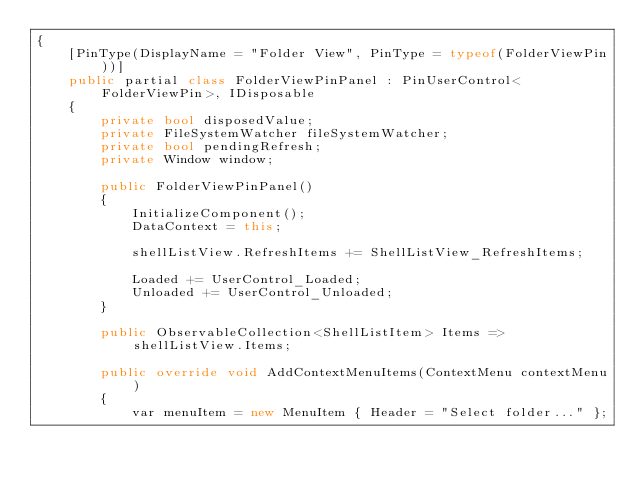<code> <loc_0><loc_0><loc_500><loc_500><_C#_>{
    [PinType(DisplayName = "Folder View", PinType = typeof(FolderViewPin))]
    public partial class FolderViewPinPanel : PinUserControl<FolderViewPin>, IDisposable
    {
        private bool disposedValue;
        private FileSystemWatcher fileSystemWatcher;
        private bool pendingRefresh;
        private Window window;

        public FolderViewPinPanel()
        {
            InitializeComponent();
            DataContext = this;

            shellListView.RefreshItems += ShellListView_RefreshItems;

            Loaded += UserControl_Loaded;
            Unloaded += UserControl_Unloaded;
        }

        public ObservableCollection<ShellListItem> Items => shellListView.Items;

        public override void AddContextMenuItems(ContextMenu contextMenu)
        {
            var menuItem = new MenuItem { Header = "Select folder..." };</code> 